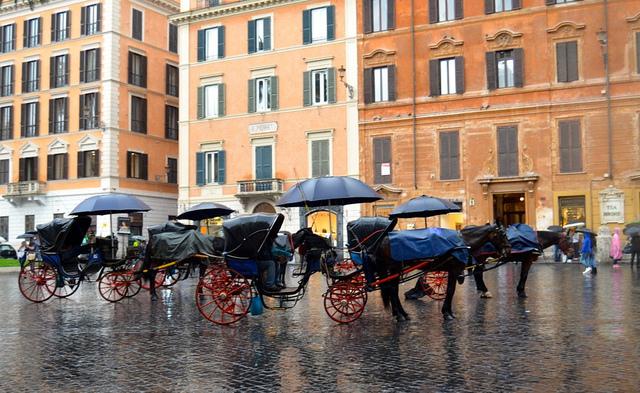What color are the wheels on the carriage?
Concise answer only. Red. Is it sunny or raining?
Quick response, please. Raining. How many umbrellas are open?
Quick response, please. 4. 